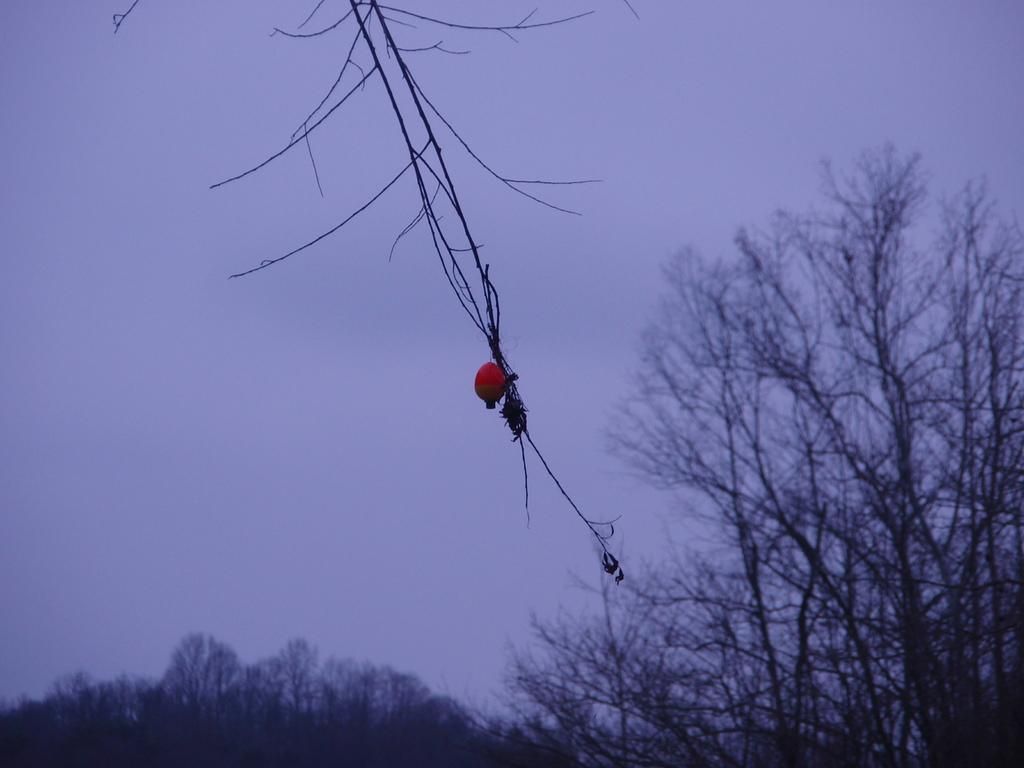What is on the tree branch in the image? There is a fruit on a tree branch in the image. What can be seen in the background of the image? There are trees and the sky visible in the background of the image. What type of feather can be seen falling from the sky in the image? There is no feather falling from the sky in the image; only the fruit, trees, and sky are present. 